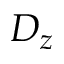<formula> <loc_0><loc_0><loc_500><loc_500>D _ { z }</formula> 